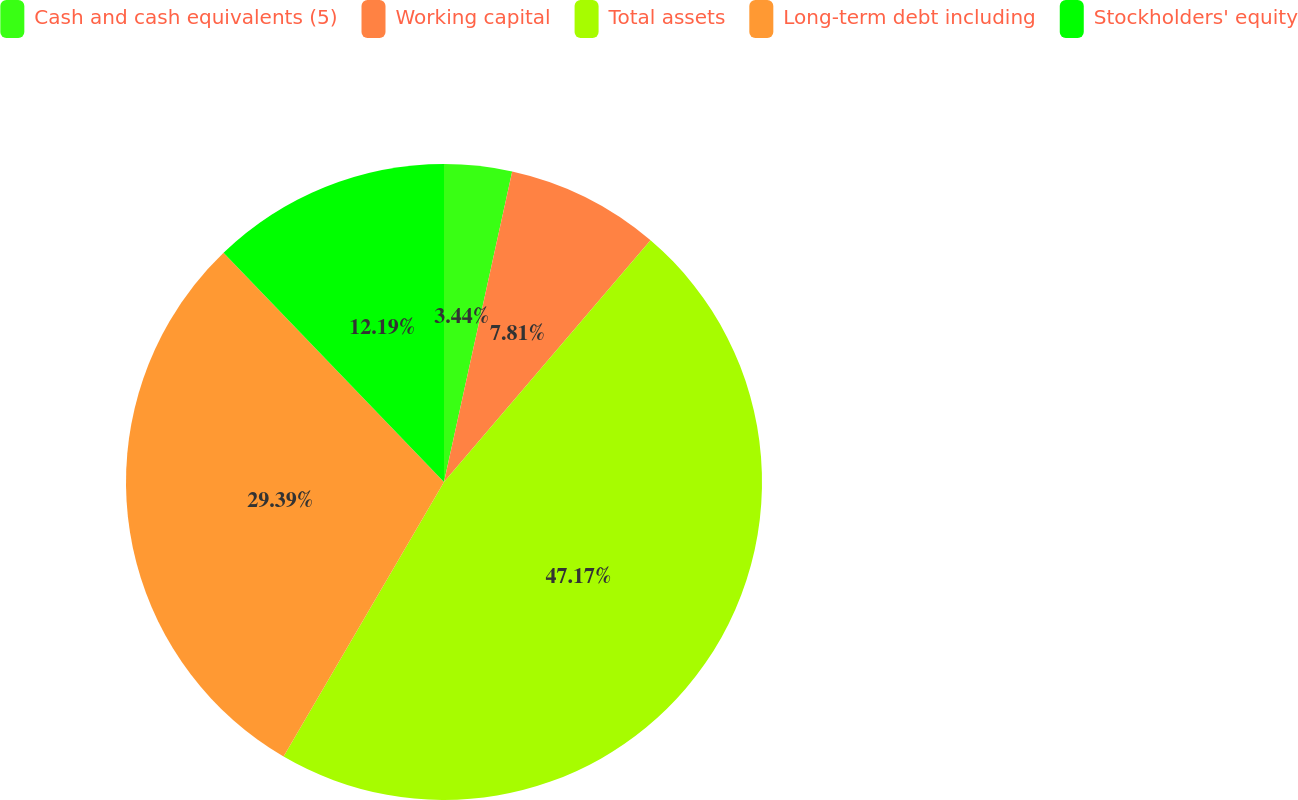Convert chart to OTSL. <chart><loc_0><loc_0><loc_500><loc_500><pie_chart><fcel>Cash and cash equivalents (5)<fcel>Working capital<fcel>Total assets<fcel>Long-term debt including<fcel>Stockholders' equity<nl><fcel>3.44%<fcel>7.81%<fcel>47.16%<fcel>29.39%<fcel>12.19%<nl></chart> 